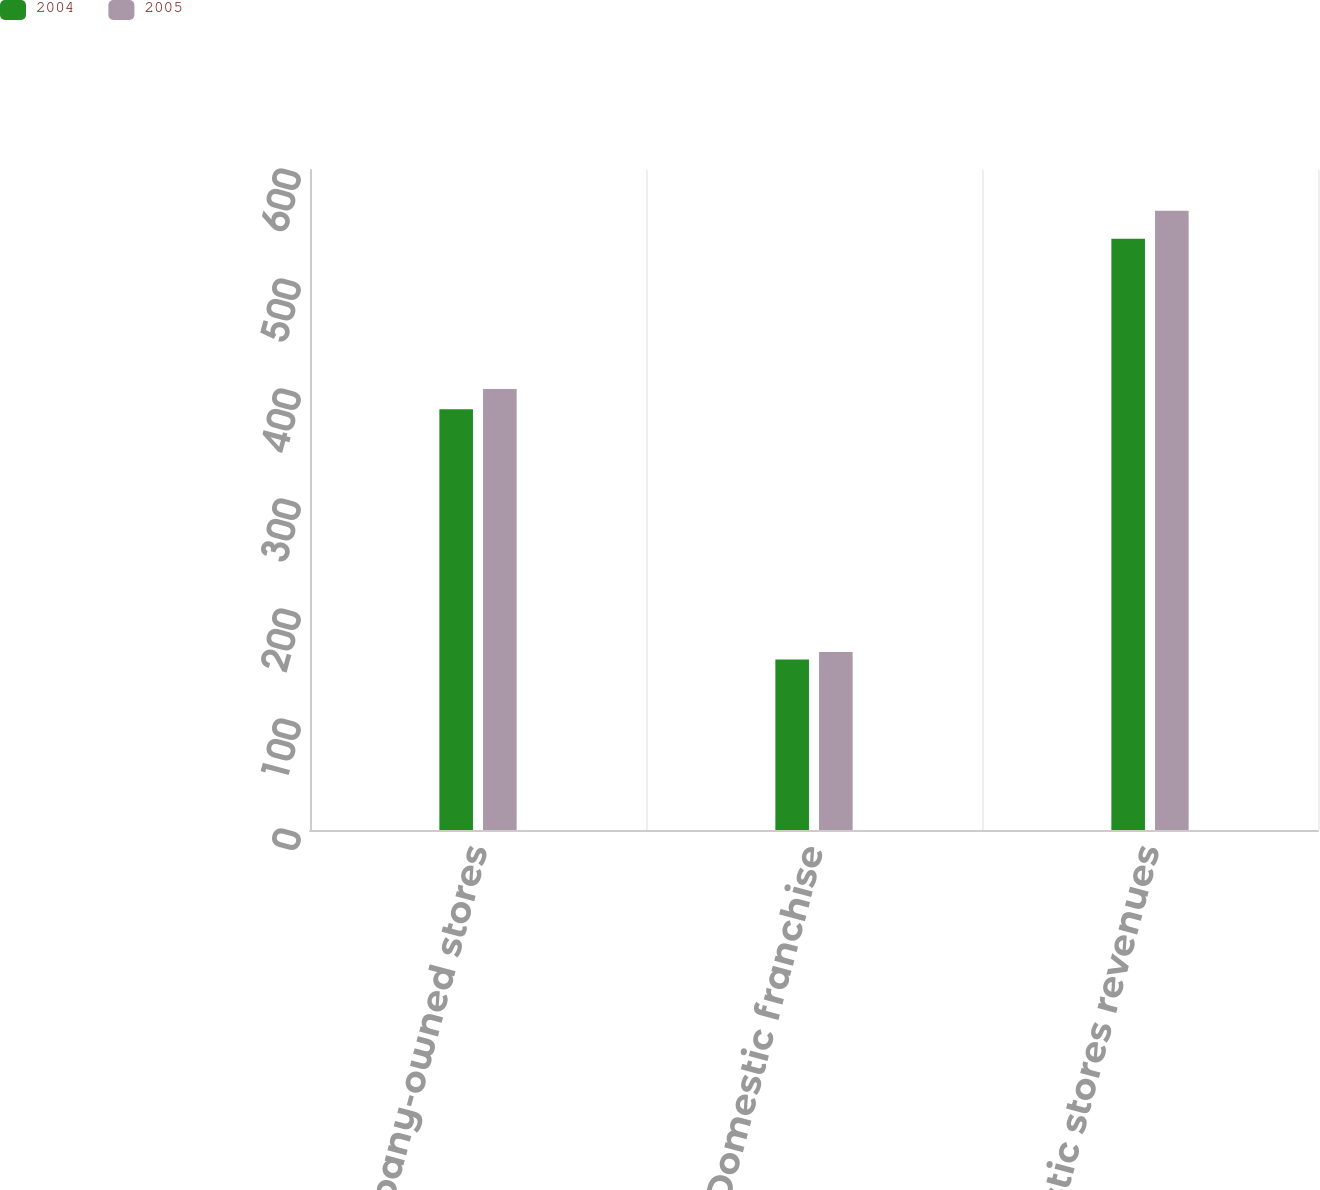<chart> <loc_0><loc_0><loc_500><loc_500><stacked_bar_chart><ecel><fcel>Domestic Company-owned stores<fcel>Domestic franchise<fcel>Total domestic stores revenues<nl><fcel>2004<fcel>382.5<fcel>155<fcel>537.5<nl><fcel>2005<fcel>401<fcel>161.9<fcel>562.9<nl></chart> 